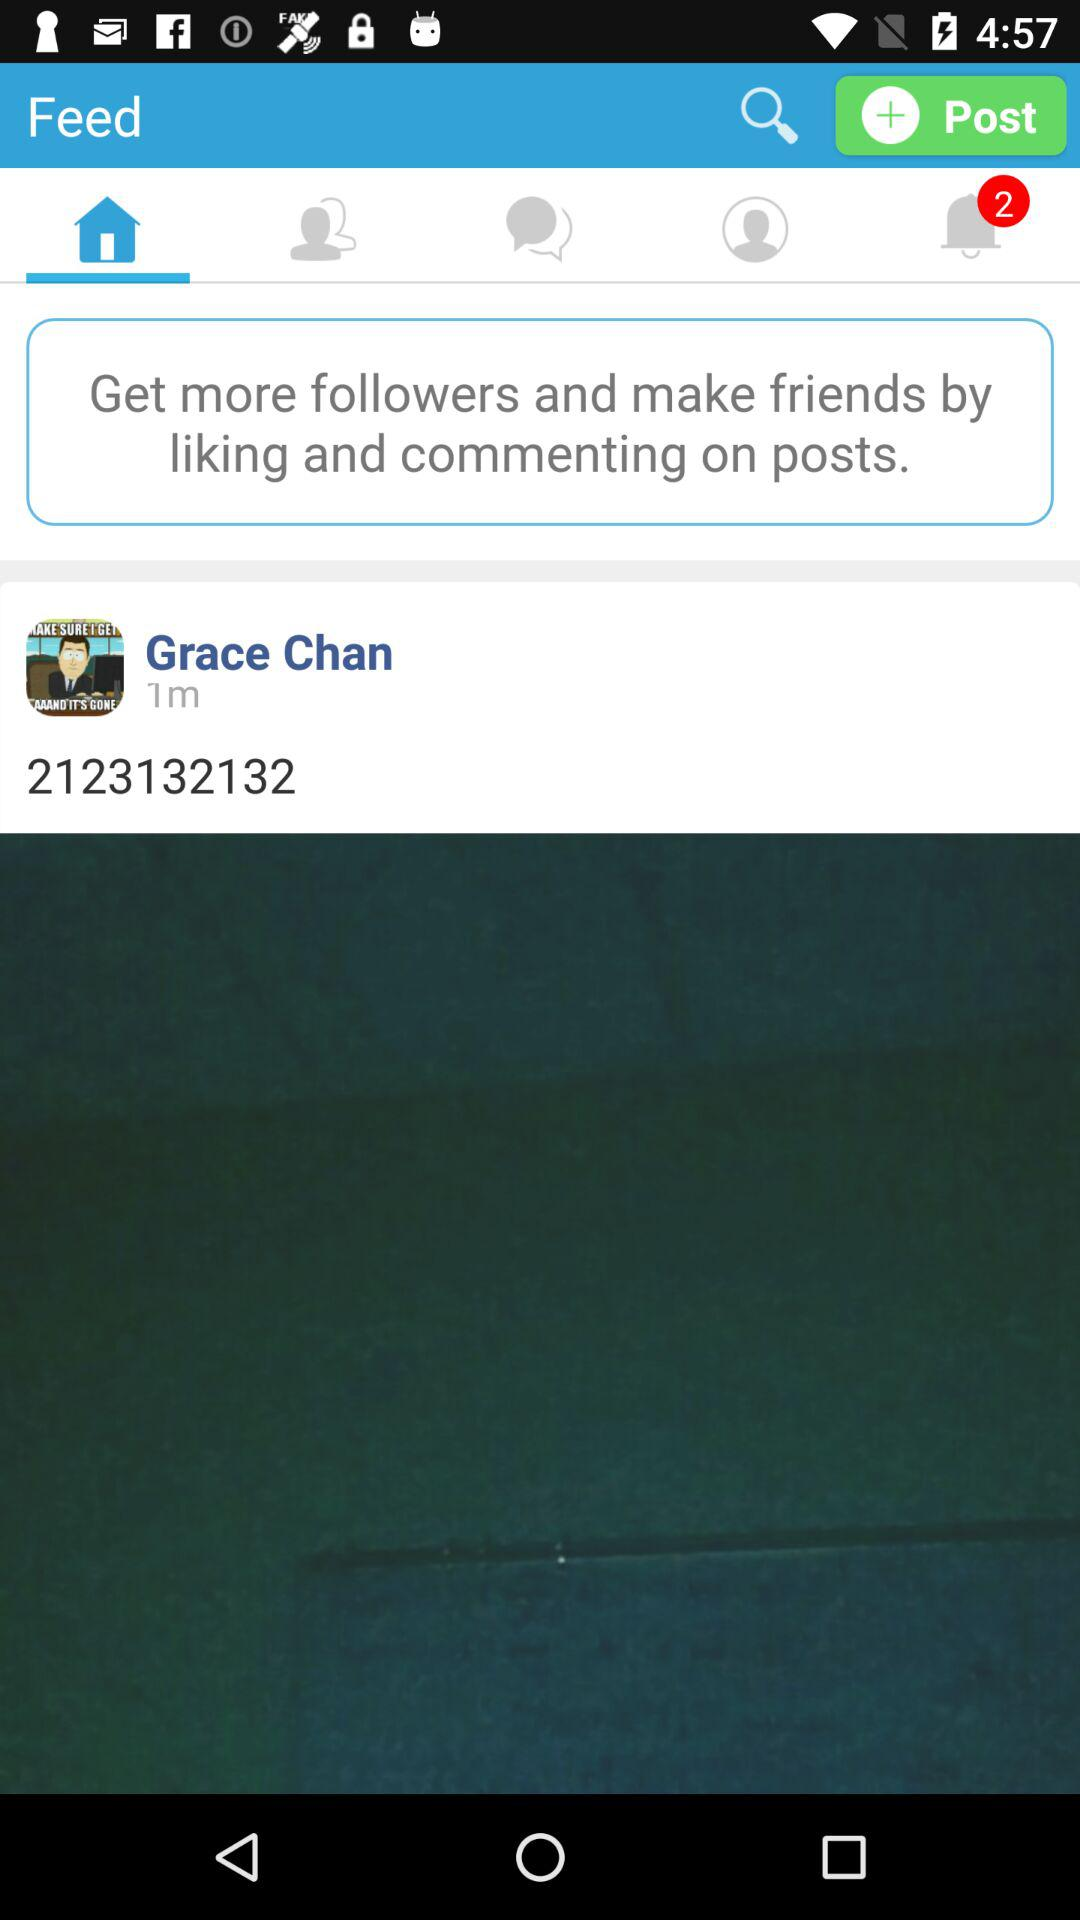Which tab is selected? The selected tab is "Home". 